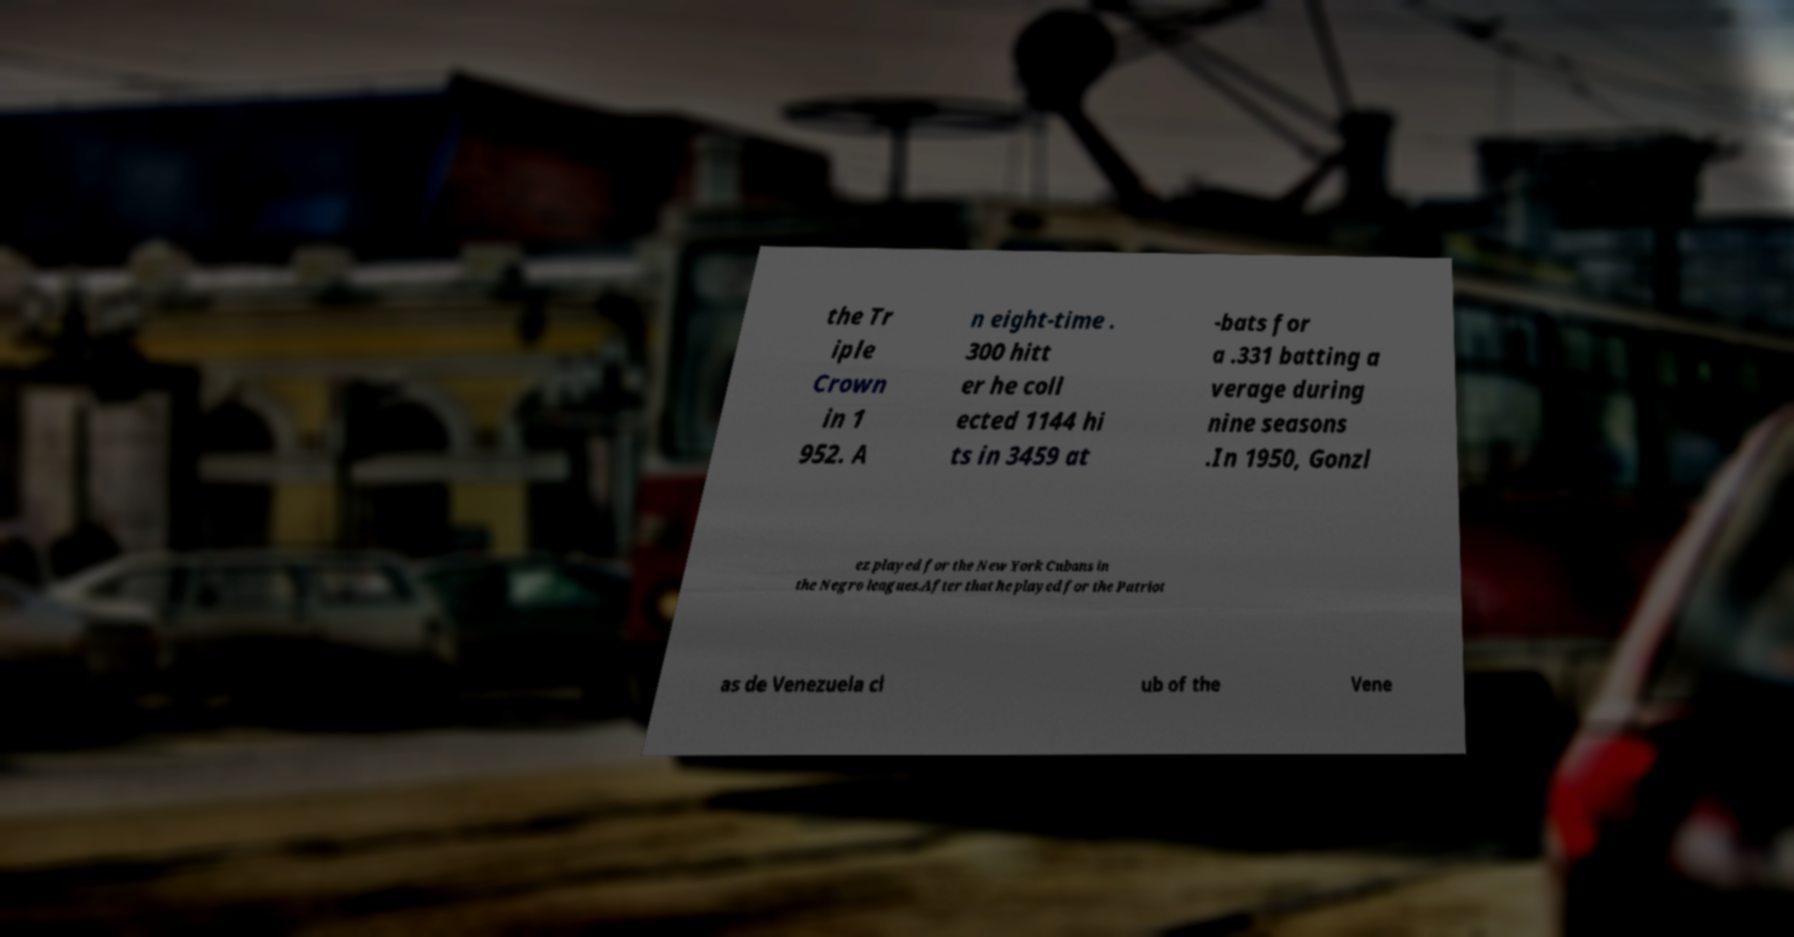Please read and relay the text visible in this image. What does it say? the Tr iple Crown in 1 952. A n eight-time . 300 hitt er he coll ected 1144 hi ts in 3459 at -bats for a .331 batting a verage during nine seasons .In 1950, Gonzl ez played for the New York Cubans in the Negro leagues.After that he played for the Patriot as de Venezuela cl ub of the Vene 